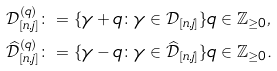<formula> <loc_0><loc_0><loc_500><loc_500>\mathcal { D } _ { [ n , j ] } ^ { ( q ) } & \colon = \{ \gamma + q \colon \gamma \in \mathcal { D } _ { [ n , j ] } \} q \in \mathbb { Z } _ { \geq 0 } , \\ \widehat { \mathcal { D } } _ { [ n , j ] } ^ { ( q ) } & \colon = \{ \gamma - q \colon \gamma \in \widehat { \mathcal { D } } _ { [ n , j ] } \} q \in \mathbb { Z } _ { \geq 0 } .</formula> 